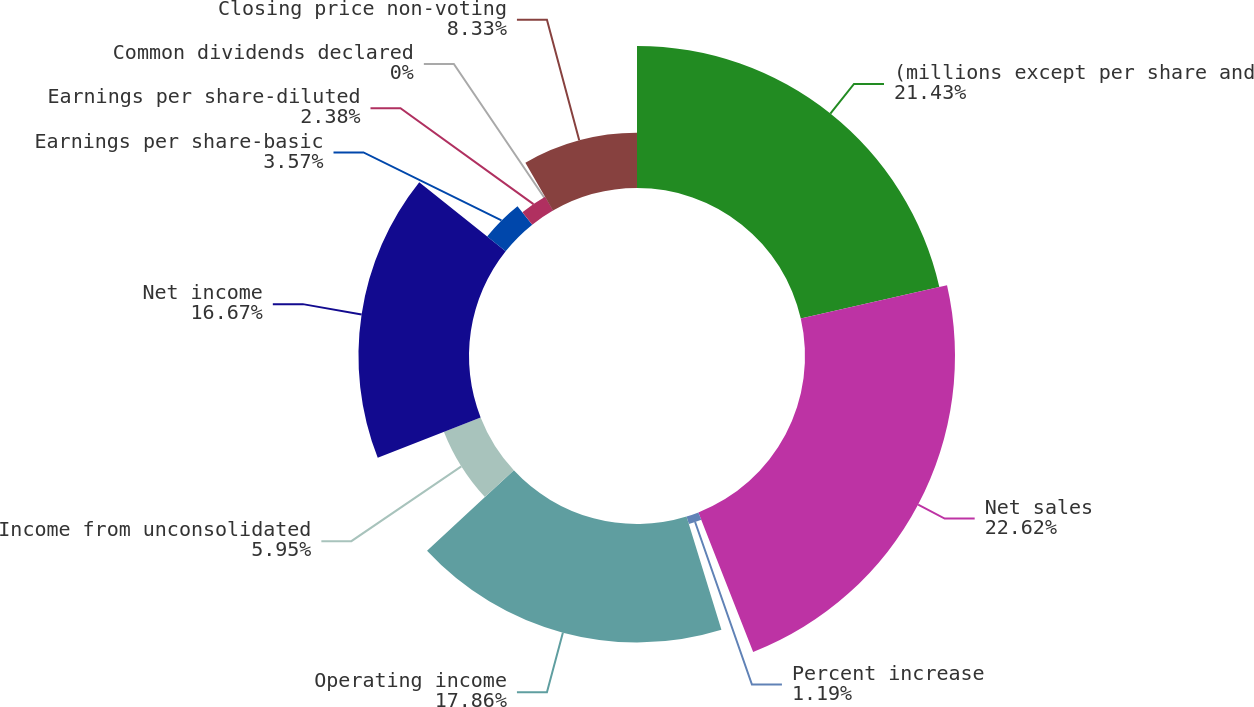Convert chart. <chart><loc_0><loc_0><loc_500><loc_500><pie_chart><fcel>(millions except per share and<fcel>Net sales<fcel>Percent increase<fcel>Operating income<fcel>Income from unconsolidated<fcel>Net income<fcel>Earnings per share-basic<fcel>Earnings per share-diluted<fcel>Common dividends declared<fcel>Closing price non-voting<nl><fcel>21.42%<fcel>22.61%<fcel>1.19%<fcel>17.85%<fcel>5.95%<fcel>16.66%<fcel>3.57%<fcel>2.38%<fcel>0.0%<fcel>8.33%<nl></chart> 